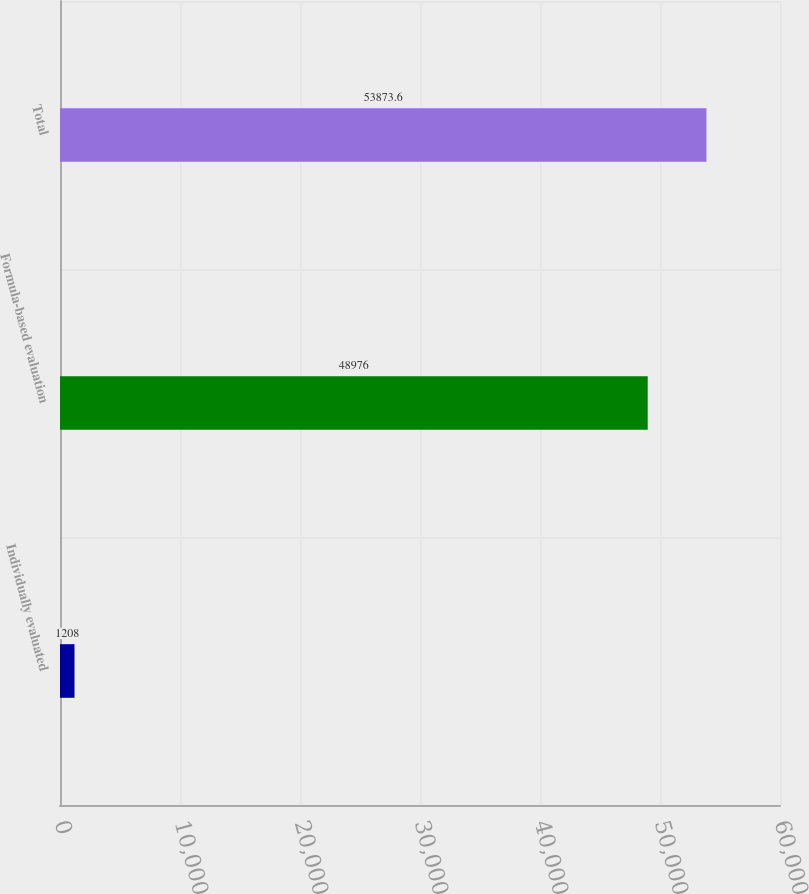<chart> <loc_0><loc_0><loc_500><loc_500><bar_chart><fcel>Individually evaluated<fcel>Formula-based evaluation<fcel>Total<nl><fcel>1208<fcel>48976<fcel>53873.6<nl></chart> 